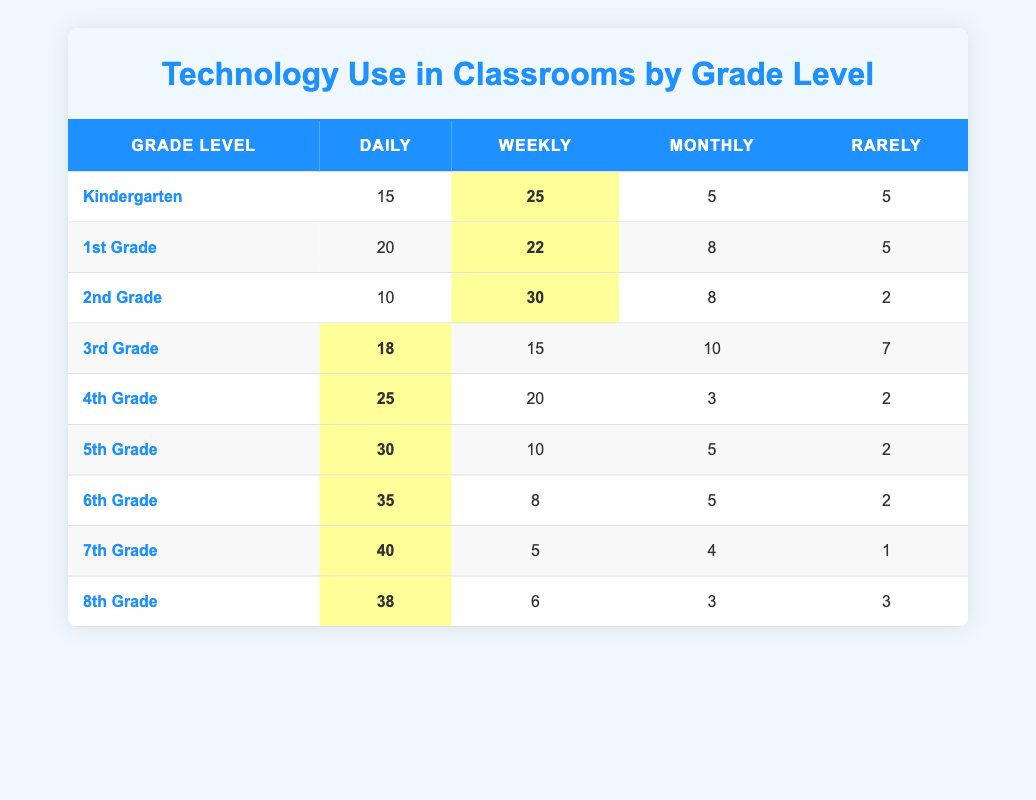What grade level has the highest frequency of daily technology use? By reviewing the "Daily" column in the table, we can see that 7th Grade has the highest value at 40.
Answer: 7th Grade What is the total frequency of technology use for 4th Grade? To find the total for 4th Grade, we sum all usage frequencies: 25 (Daily) + 20 (Weekly) + 3 (Monthly) + 2 (Rarely) = 50.
Answer: 50 How many students in 6th Grade use technology weekly? Looking at the "Weekly" column for 6th Grade, it shows a frequency of 8 students.
Answer: 8 Which grade level has a frequency of technology use that is rarely 2 students? By checking the "Rarely" column, we find that both 4th Grade and 5th Grade have a frequency of 2 for rarely using technology.
Answer: 4th Grade and 5th Grade What is the average number of students for technology use across all grades on a daily basis? First, we sum the daily frequencies: 15 + 20 + 10 + 18 + 25 + 30 + 35 + 40 + 38 = 231. There are 9 grade levels, so the average is 231 / 9 = 25.67.
Answer: 25.67 Is it true that 3rd Grade has more weekly technology use than 5th Grade? Comparing the "Weekly" column, we see that 3rd Grade has 15, while 5th Grade has 10. Thus, 3rd Grade does have more.
Answer: Yes What is the difference in daily technology use between 5th Grade and 1st Grade? For 5th Grade, the daily frequency is 30; for 1st Grade, it is 20. The difference is 30 - 20 = 10.
Answer: 10 Which grade level uses technology less frequently on a monthly basis than 2nd Grade? From the "Monthly" column, 2nd Grade has a frequency of 8. The grade levels with a lower frequency are Kindergarten (5), 4th Grade (3), 5th Grade (5), 6th Grade (5), 7th Grade (4), and 8th Grade (3).
Answer: Kindergarten, 4th Grade, 5th Grade, 6th Grade, 7th Grade, 8th Grade 